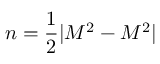Convert formula to latex. <formula><loc_0><loc_0><loc_500><loc_500>n = { \frac { 1 } { 2 } } | M ^ { 2 } - M ^ { 2 } |</formula> 